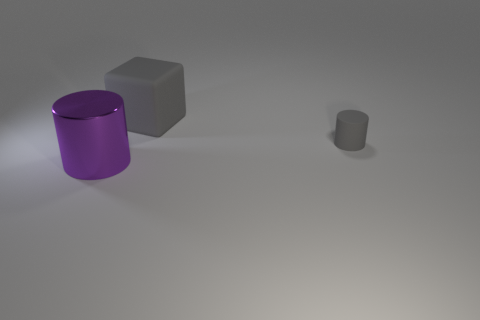Is there any other thing that has the same size as the gray cylinder?
Your answer should be very brief. No. There is a object that is behind the purple metallic cylinder and in front of the big gray cube; how big is it?
Offer a terse response. Small. What number of other objects are there of the same shape as the small gray thing?
Provide a succinct answer. 1. There is a gray rubber cylinder; how many tiny cylinders are right of it?
Provide a succinct answer. 0. Is the number of things in front of the purple metal cylinder less than the number of gray matte cylinders that are to the right of the matte cube?
Provide a short and direct response. Yes. The large object that is right of the cylinder that is in front of the matte thing that is in front of the large gray thing is what shape?
Your answer should be very brief. Cube. The thing that is on the right side of the shiny thing and left of the tiny gray thing has what shape?
Provide a short and direct response. Cube. Are there any cyan cylinders that have the same material as the cube?
Ensure brevity in your answer.  No. There is another thing that is the same color as the large matte object; what is its size?
Offer a very short reply. Small. The big object that is behind the tiny gray rubber thing is what color?
Give a very brief answer. Gray. 